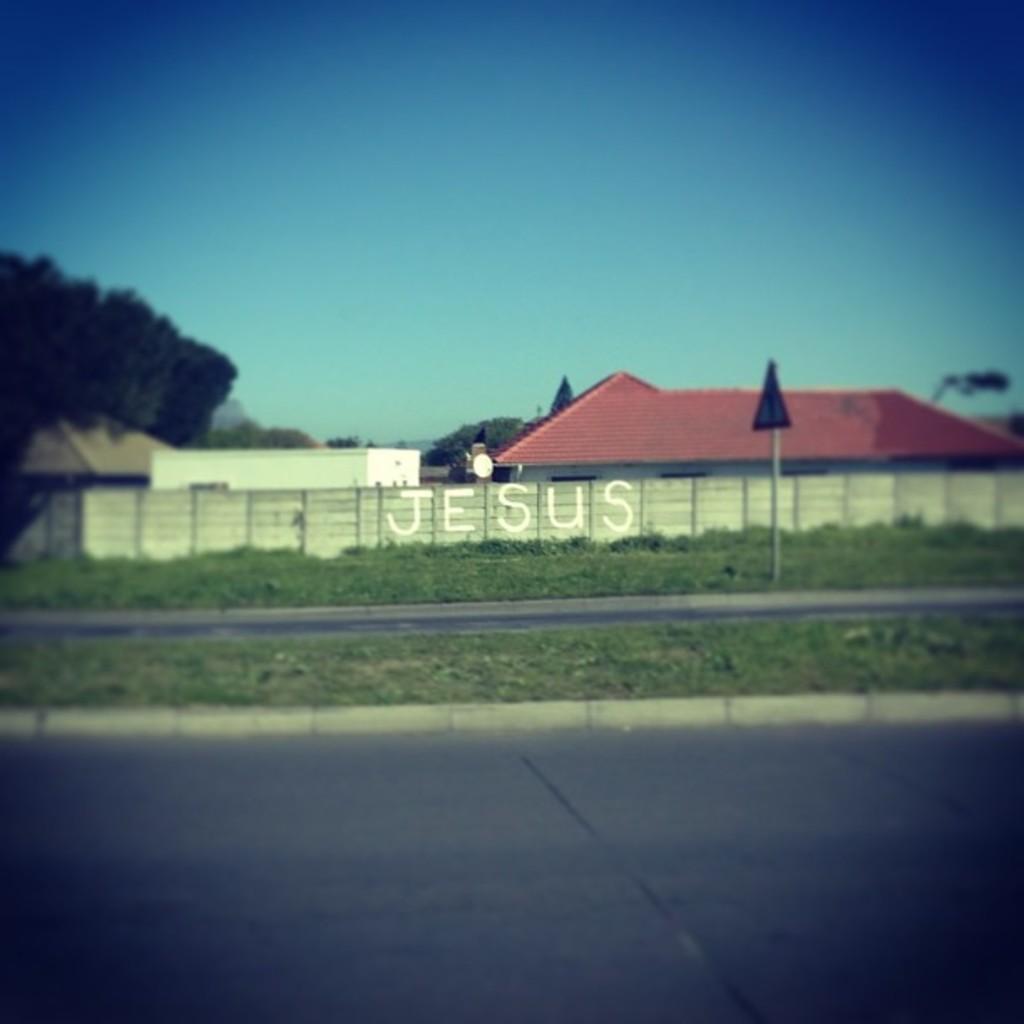Can you describe this image briefly? In this image, we can see houses, trees, walls, plants, roads, pole, board and sky. In the image, we can see some text. 